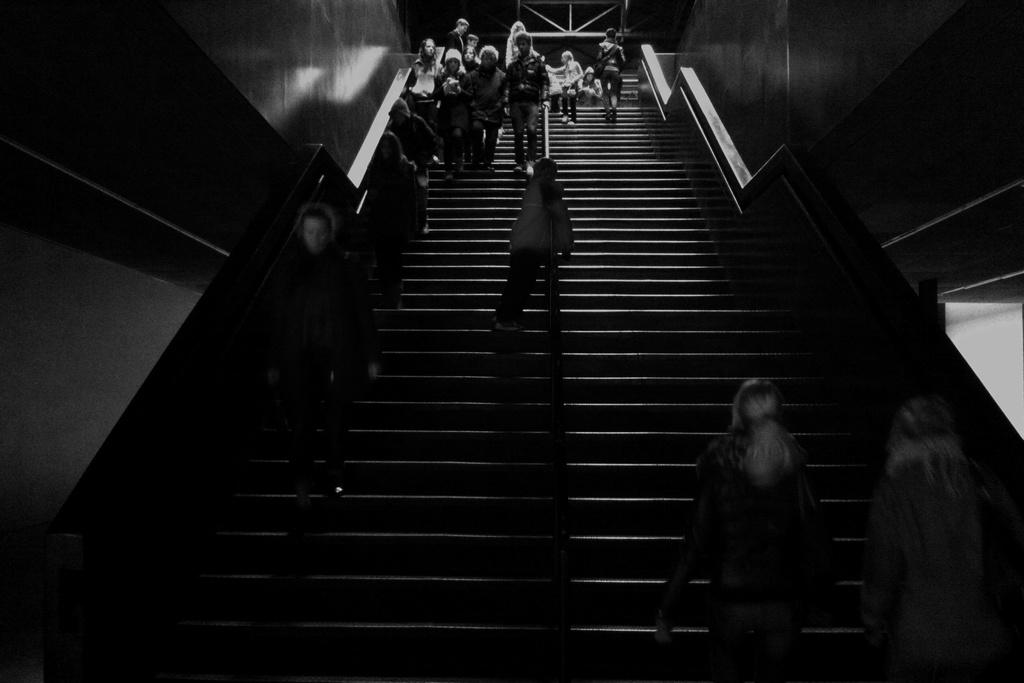What is the lighting condition in the image? The image was taken in the dark. What can be seen happening on the streets in the image? There are people walking on the streets in the image. What structures are visible on the sides of the image? There are walls visible on the right and left sides of the image. How many beds can be seen in the image? There are no beds present in the image. What type of thing is flying in the sky in the image? There is no thing flying in the sky in the image. 